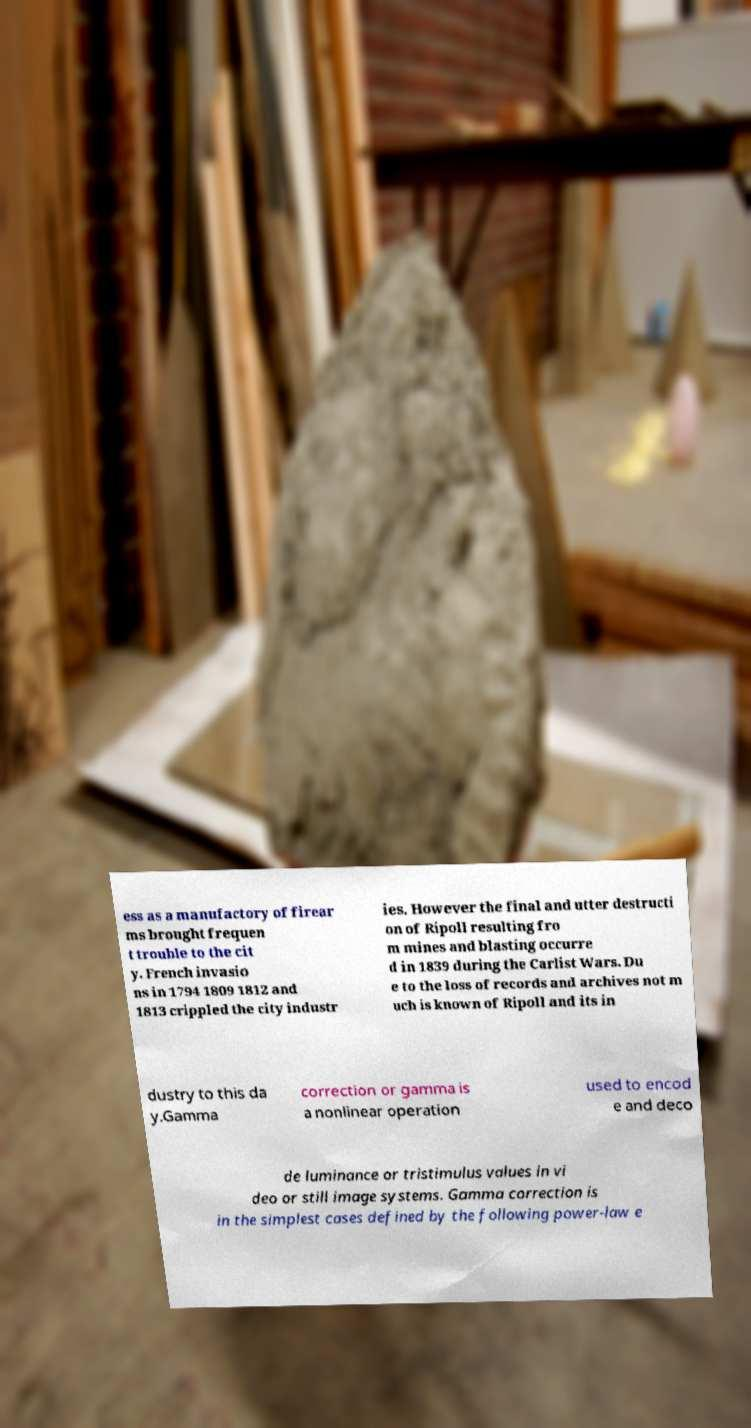Can you accurately transcribe the text from the provided image for me? ess as a manufactory of firear ms brought frequen t trouble to the cit y. French invasio ns in 1794 1809 1812 and 1813 crippled the city industr ies. However the final and utter destructi on of Ripoll resulting fro m mines and blasting occurre d in 1839 during the Carlist Wars. Du e to the loss of records and archives not m uch is known of Ripoll and its in dustry to this da y.Gamma correction or gamma is a nonlinear operation used to encod e and deco de luminance or tristimulus values in vi deo or still image systems. Gamma correction is in the simplest cases defined by the following power-law e 